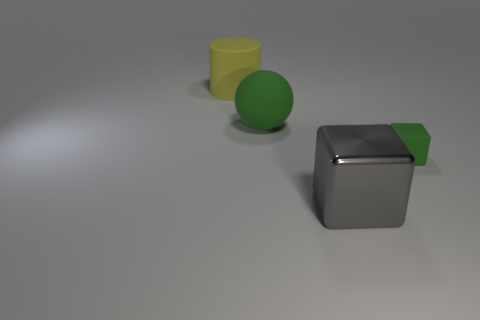Are there any other things that are the same size as the rubber block?
Keep it short and to the point. No. Are the large object in front of the green rubber sphere and the yellow object made of the same material?
Keep it short and to the point. No. How big is the green matte sphere?
Keep it short and to the point. Large. What color is the cylinder that is the same size as the gray block?
Your answer should be compact. Yellow. What number of things are brown metal spheres or green rubber balls?
Provide a short and direct response. 1. Are there any matte things right of the large green sphere?
Provide a succinct answer. Yes. Are there any big gray things that have the same material as the large gray cube?
Provide a short and direct response. No. There is a cube that is the same color as the matte ball; what is its size?
Your answer should be very brief. Small. What number of spheres are big rubber things or tiny rubber objects?
Provide a short and direct response. 1. Is the number of gray shiny objects that are behind the big yellow thing greater than the number of metal blocks that are in front of the big metallic object?
Make the answer very short. No. 